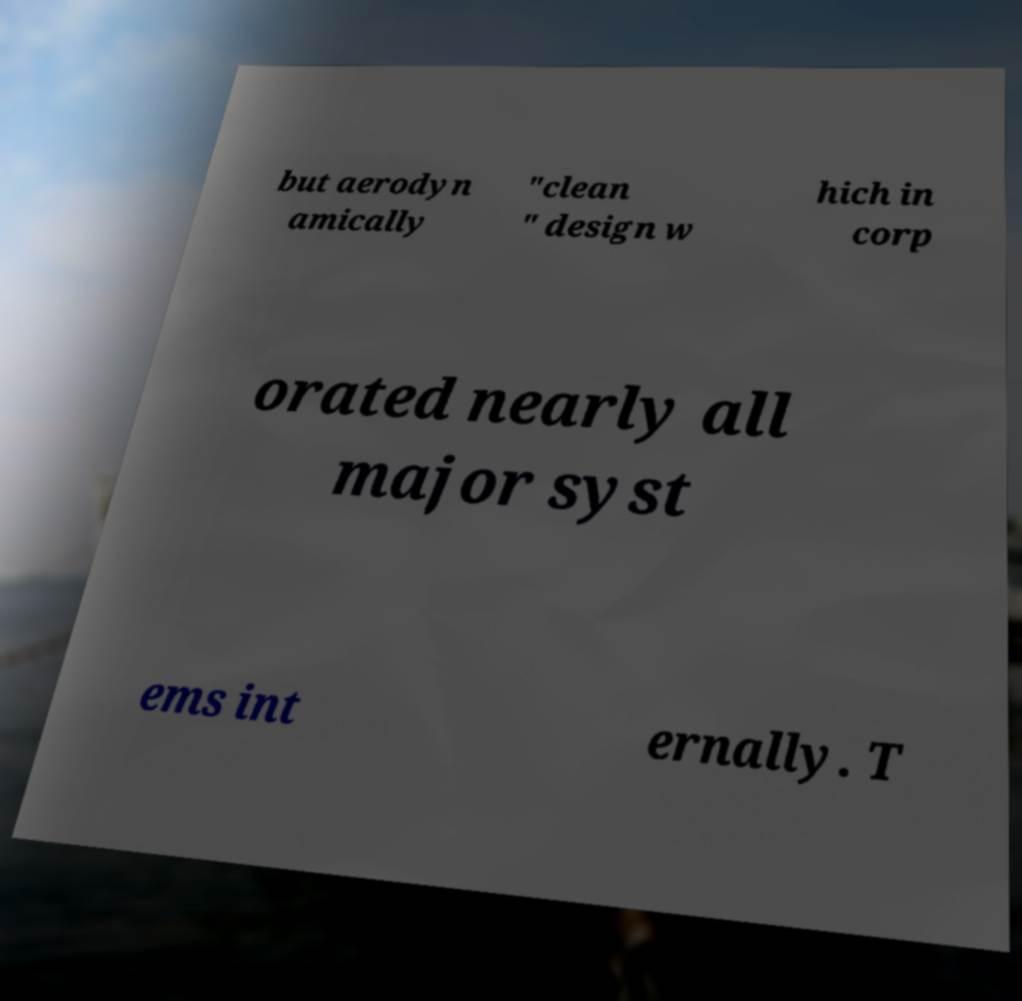Could you assist in decoding the text presented in this image and type it out clearly? but aerodyn amically "clean " design w hich in corp orated nearly all major syst ems int ernally. T 